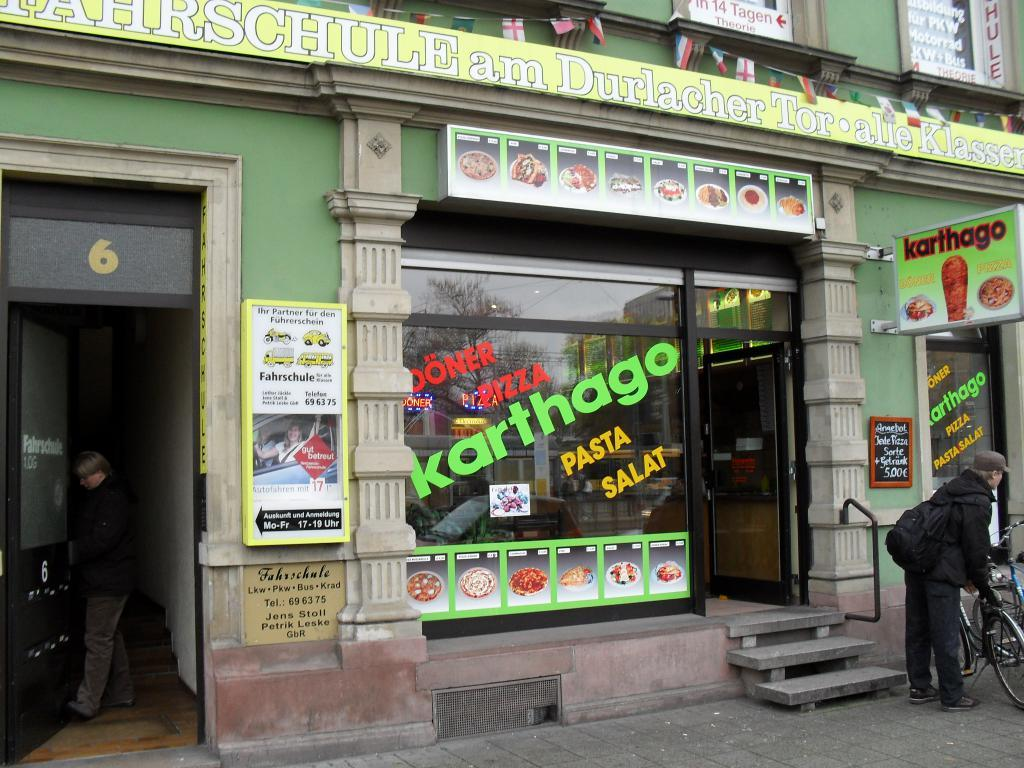What type of structure is visible in the image? There is a building in the image. What is attached to the building? There is a hoarding and flags in the image. Who or what can be seen in the image? There are people and bicycles in the image. What architectural feature is present in the image? There are steps in the image. What other objects can be seen in the image? There are doors, images, and boards in the image. What is written on the glass windows in the image? There is writing on the glass windows in the image. Can you tell me how many beggars are visible in the image? There is no beggar present in the image. What type of train can be seen passing by the building in the image? There is no train present in the image. 